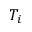Convert formula to latex. <formula><loc_0><loc_0><loc_500><loc_500>T _ { i }</formula> 